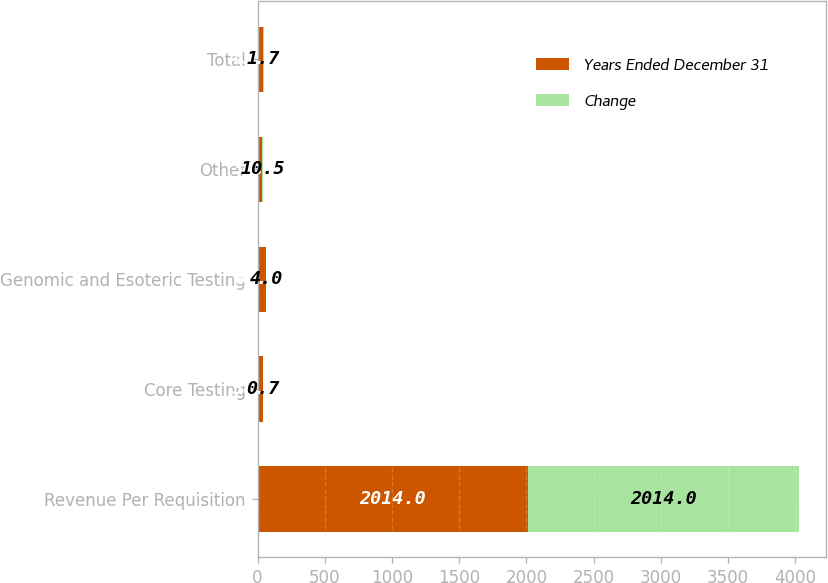Convert chart. <chart><loc_0><loc_0><loc_500><loc_500><stacked_bar_chart><ecel><fcel>Revenue Per Requisition<fcel>Core Testing<fcel>Genomic and Esoteric Testing<fcel>Other<fcel>Total<nl><fcel>Years Ended December 31<fcel>2014<fcel>38.56<fcel>62.25<fcel>30.89<fcel>43.56<nl><fcel>Change<fcel>2014<fcel>0.7<fcel>4<fcel>10.5<fcel>1.7<nl></chart> 